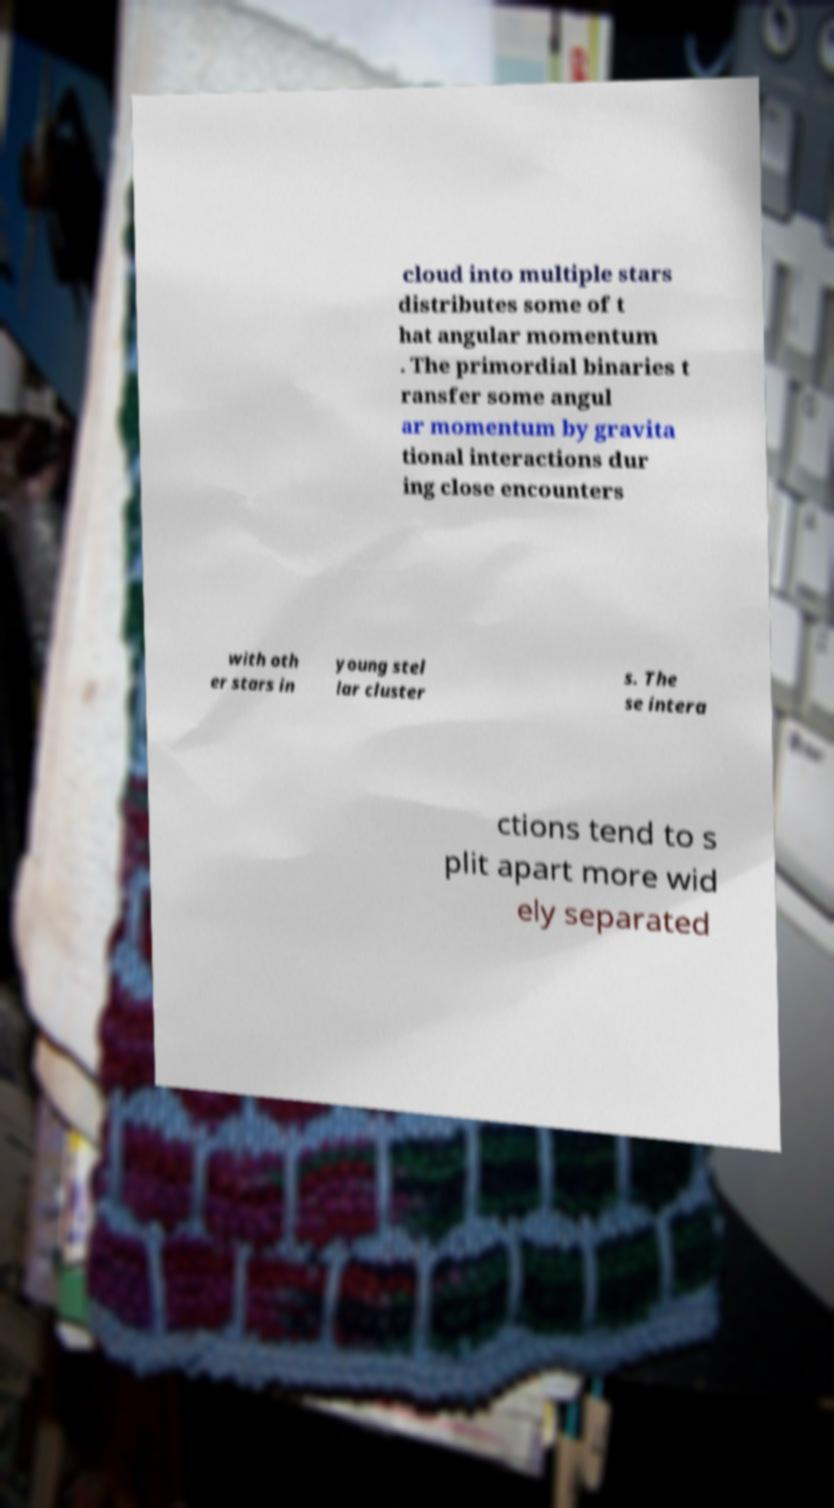Can you read and provide the text displayed in the image?This photo seems to have some interesting text. Can you extract and type it out for me? cloud into multiple stars distributes some of t hat angular momentum . The primordial binaries t ransfer some angul ar momentum by gravita tional interactions dur ing close encounters with oth er stars in young stel lar cluster s. The se intera ctions tend to s plit apart more wid ely separated 